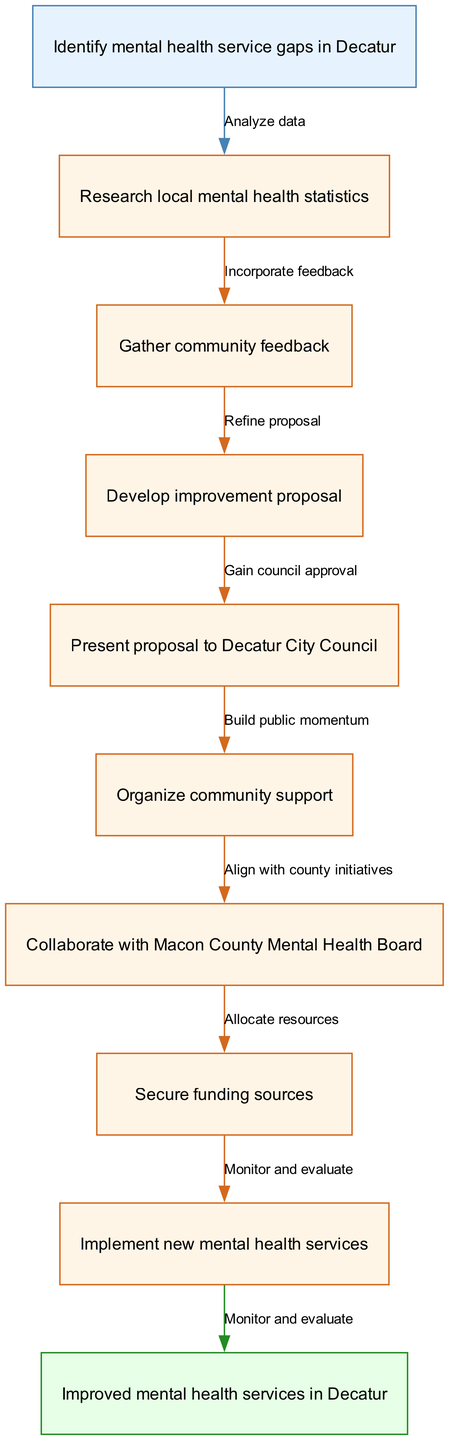What is the starting node in the process? The diagram indicates that the starting node is "Identify mental health service gaps in Decatur", which initiates the flow of the process.
Answer: Identify mental health service gaps in Decatur How many intermediate nodes are there? Counting the nodes listed in the diagram, there are 7 intermediate nodes between the start node and the end node.
Answer: 7 What action follows the "Gather community feedback" node? The edge from "Gather community feedback" leads to the next node, "Develop improvement proposal", indicating this is the next action taken after gathering feedback.
Answer: Develop improvement proposal What is the final action in the process? The edge leading to the end node shows that the last action in the process is "Implement new mental health services".
Answer: Implement new mental health services Which node does the "Refine proposal" edge connect to? The "Refine proposal" edge connects the node "Develop improvement proposal" to "Present proposal to Decatur City Council", indicating that refining the proposal is a step before presenting.
Answer: Present proposal to Decatur City Council How does one ensure community support? The "Organize community support" node suggests that building momentum and public interest is necessary to establish support for the proposal.
Answer: Organize community support What must be accomplished before implementing new mental health services? The flow indicates that "Secure funding sources" must be successfully completed to allocate resources before the implementation stage.
Answer: Secure funding sources How does the "Analyze data" action contribute to the process? "Analyze data" is the first action representing the foundation of identifying gaps in mental health services, enabling informed steps throughout the process.
Answer: Research local mental health statistics Which two nodes are connected by the edge "Gain council approval"? The edge "Gain council approval" connects the nodes "Present proposal to Decatur City Council" and "Implement new mental health services", signifying that council approval is necessary to proceed.
Answer: Present proposal to Decatur City Council and Implement new mental health services 